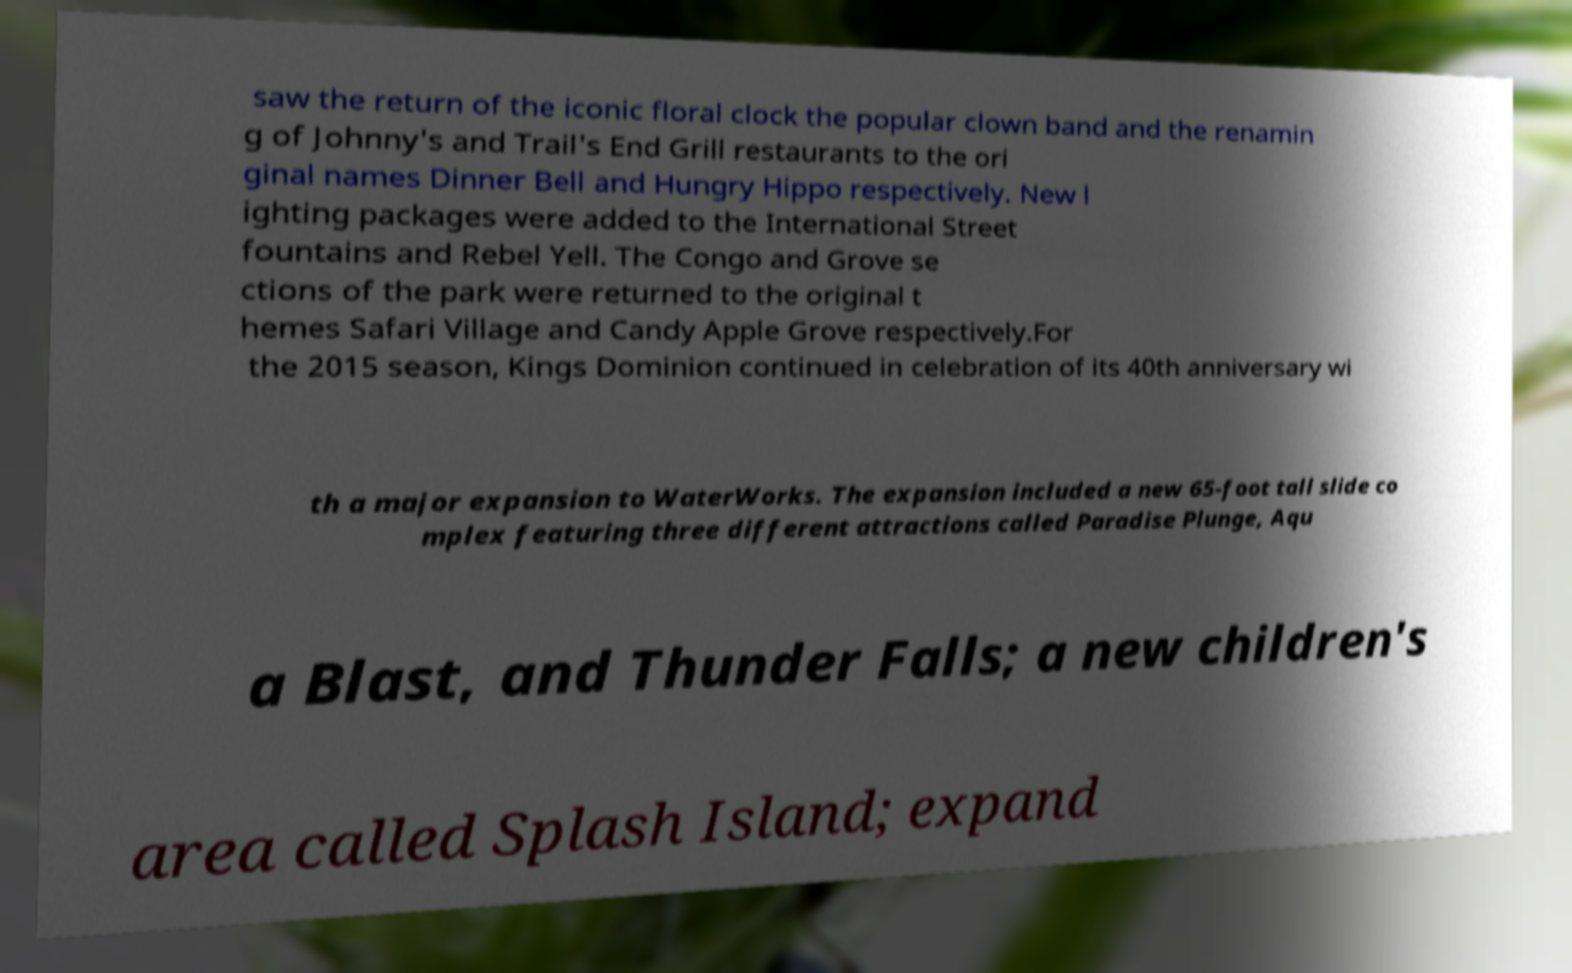Could you assist in decoding the text presented in this image and type it out clearly? saw the return of the iconic floral clock the popular clown band and the renamin g of Johnny's and Trail's End Grill restaurants to the ori ginal names Dinner Bell and Hungry Hippo respectively. New l ighting packages were added to the International Street fountains and Rebel Yell. The Congo and Grove se ctions of the park were returned to the original t hemes Safari Village and Candy Apple Grove respectively.For the 2015 season, Kings Dominion continued in celebration of its 40th anniversary wi th a major expansion to WaterWorks. The expansion included a new 65-foot tall slide co mplex featuring three different attractions called Paradise Plunge, Aqu a Blast, and Thunder Falls; a new children's area called Splash Island; expand 